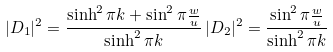Convert formula to latex. <formula><loc_0><loc_0><loc_500><loc_500>| D _ { 1 } | ^ { 2 } = \frac { \sinh ^ { 2 } { \pi k } + \sin ^ { 2 } { \pi \frac { w } { u } } } { \sinh ^ { 2 } { \pi k } } \, | D _ { 2 } | ^ { 2 } = \frac { \sin ^ { 2 } { \pi \frac { w } { u } } } { \sinh ^ { 2 } { \pi k } }</formula> 